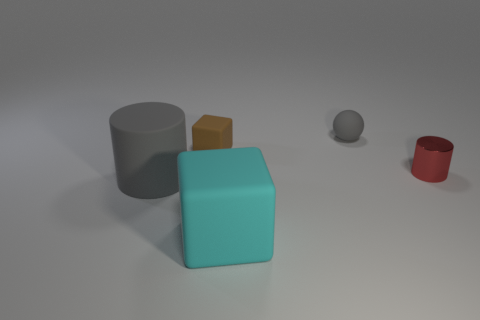If I were to group the objects by texture, which groups would emerge? It's not possible to determine textures with certainty from the image, but if we infer based on their appearance, the gray cylinder and the red cylinder seem to have a smooth texture, suggesting they could be made out of a material like metal or plastic. The teal and yellow cubes appear to have a matte surface that could suggest a less reflective material like rubber or painted wood. 